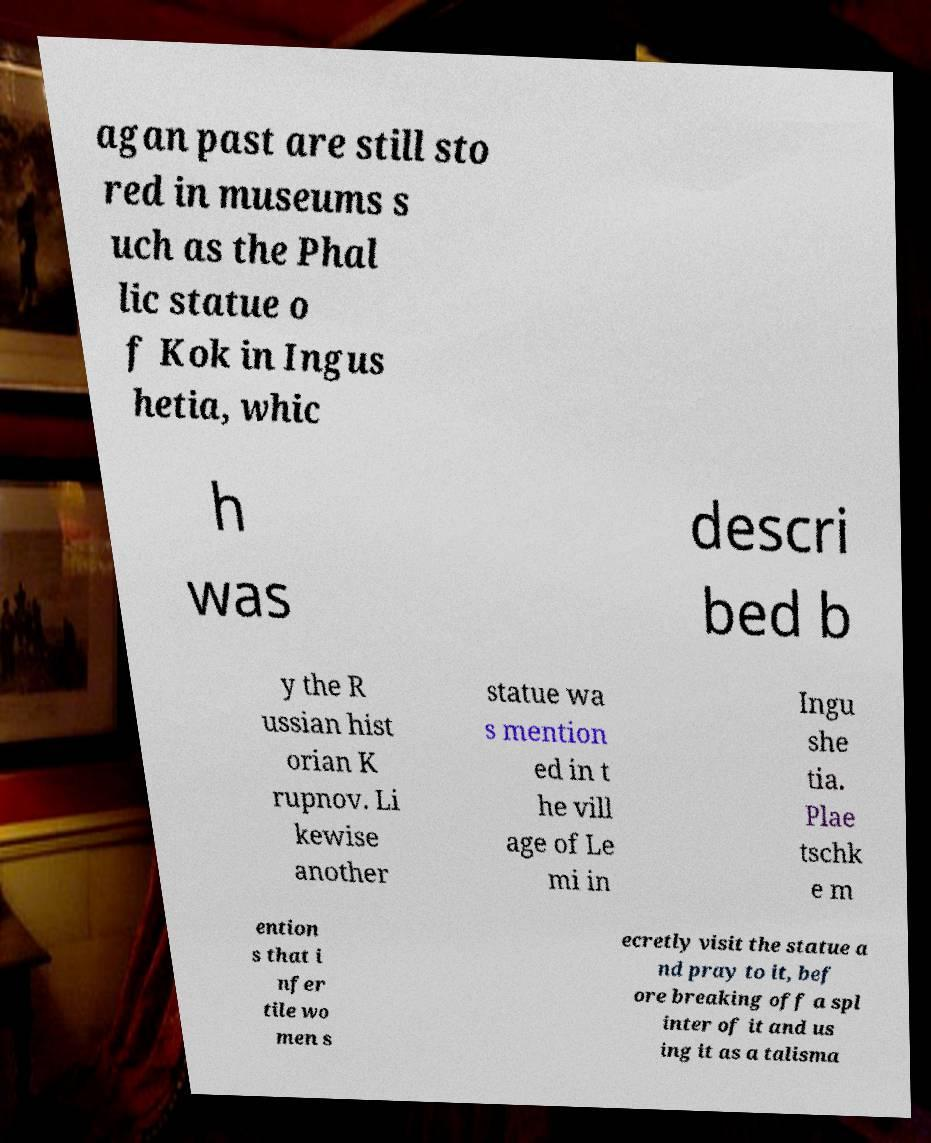Can you read and provide the text displayed in the image?This photo seems to have some interesting text. Can you extract and type it out for me? agan past are still sto red in museums s uch as the Phal lic statue o f Kok in Ingus hetia, whic h was descri bed b y the R ussian hist orian K rupnov. Li kewise another statue wa s mention ed in t he vill age of Le mi in Ingu she tia. Plae tschk e m ention s that i nfer tile wo men s ecretly visit the statue a nd pray to it, bef ore breaking off a spl inter of it and us ing it as a talisma 